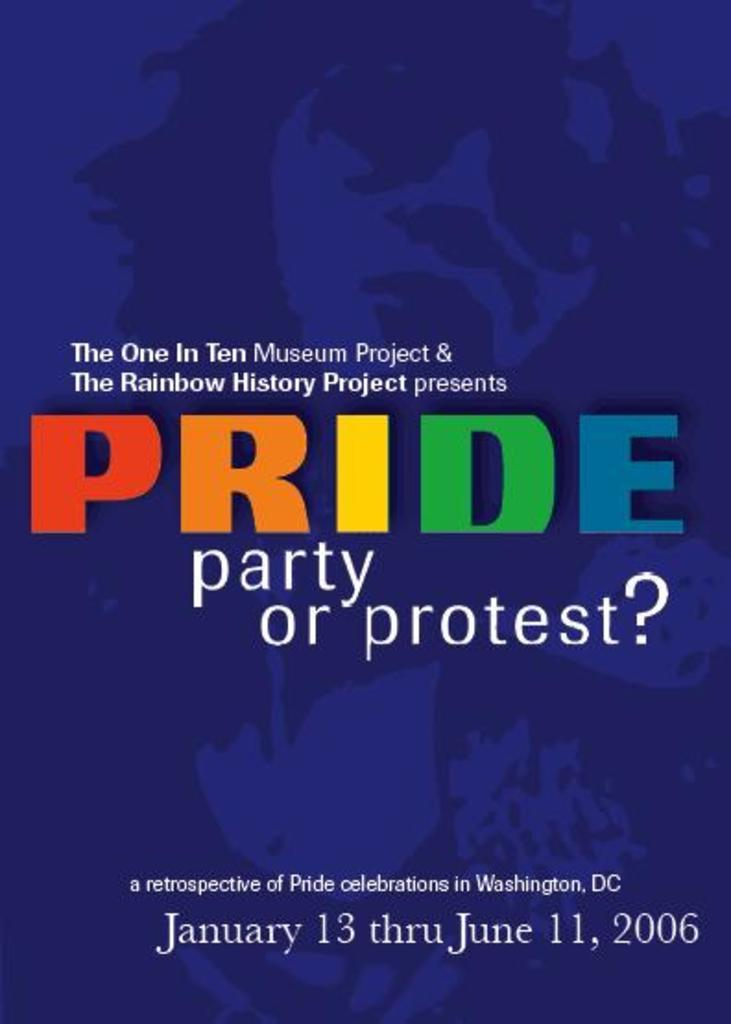<image>
Render a clear and concise summary of the photo. poster advertising pride party in washington, dc january 13 thru june 11, 2006 